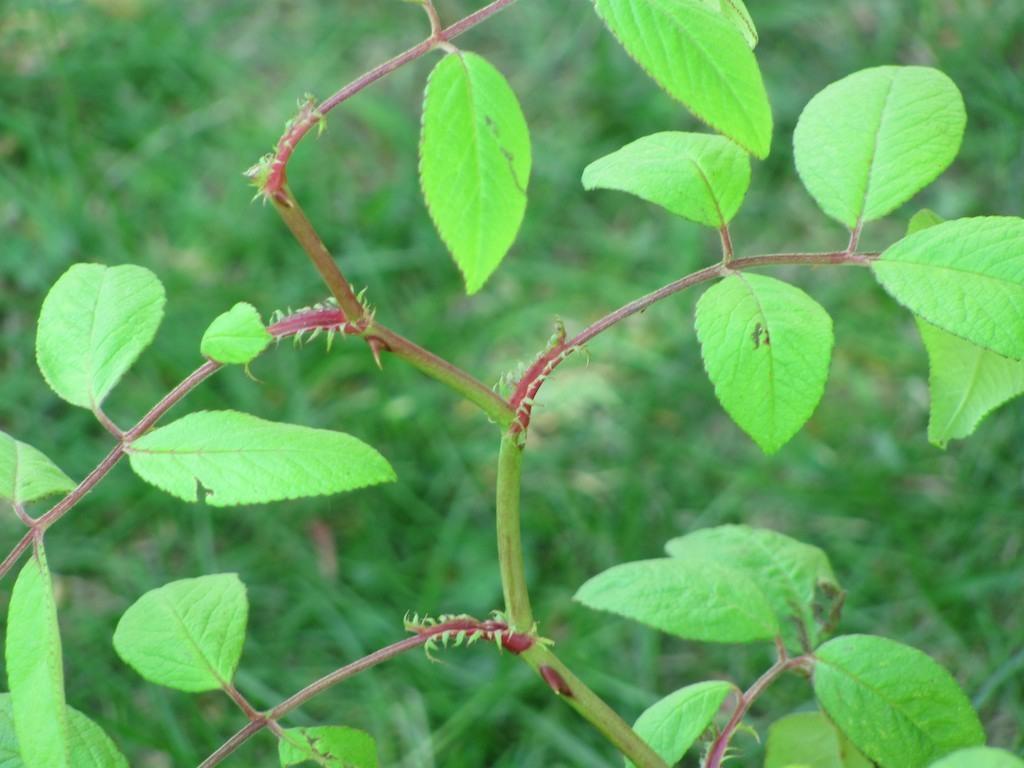How would you summarize this image in a sentence or two? In this picture I can see the plants. 